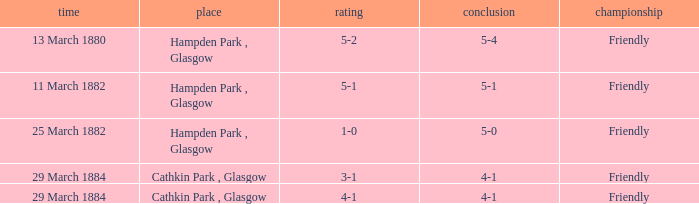Which item has a score of 5-1? 5-1. 